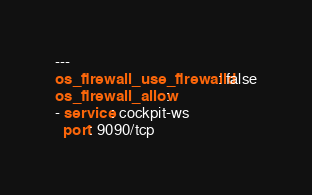<code> <loc_0><loc_0><loc_500><loc_500><_YAML_>---
os_firewall_use_firewalld: false
os_firewall_allow:
- service: cockpit-ws
  port: 9090/tcp
</code> 